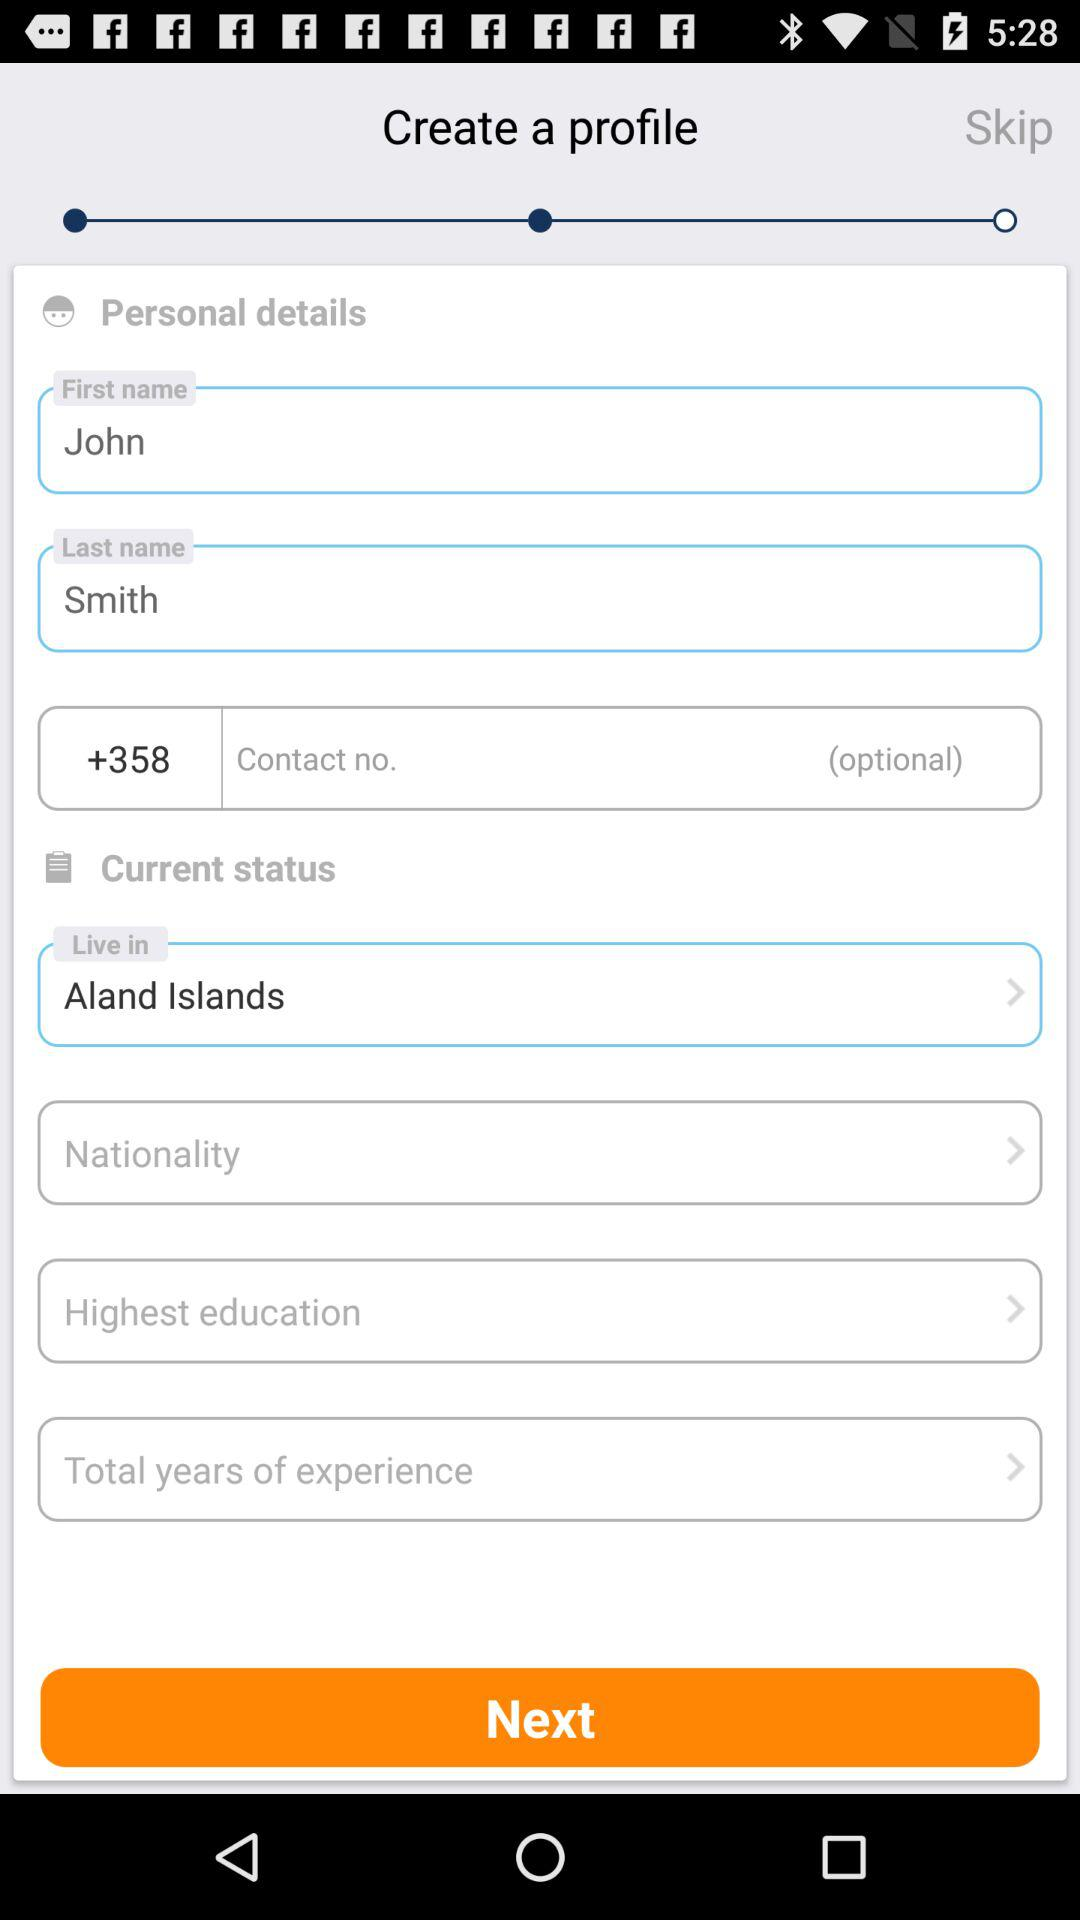What is a phone code? The phone code is +358. 